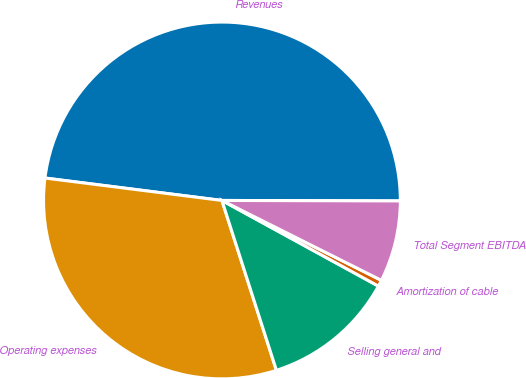Convert chart to OTSL. <chart><loc_0><loc_0><loc_500><loc_500><pie_chart><fcel>Revenues<fcel>Operating expenses<fcel>Selling general and<fcel>Amortization of cable<fcel>Total Segment EBITDA<nl><fcel>48.04%<fcel>31.95%<fcel>12.09%<fcel>0.58%<fcel>7.35%<nl></chart> 